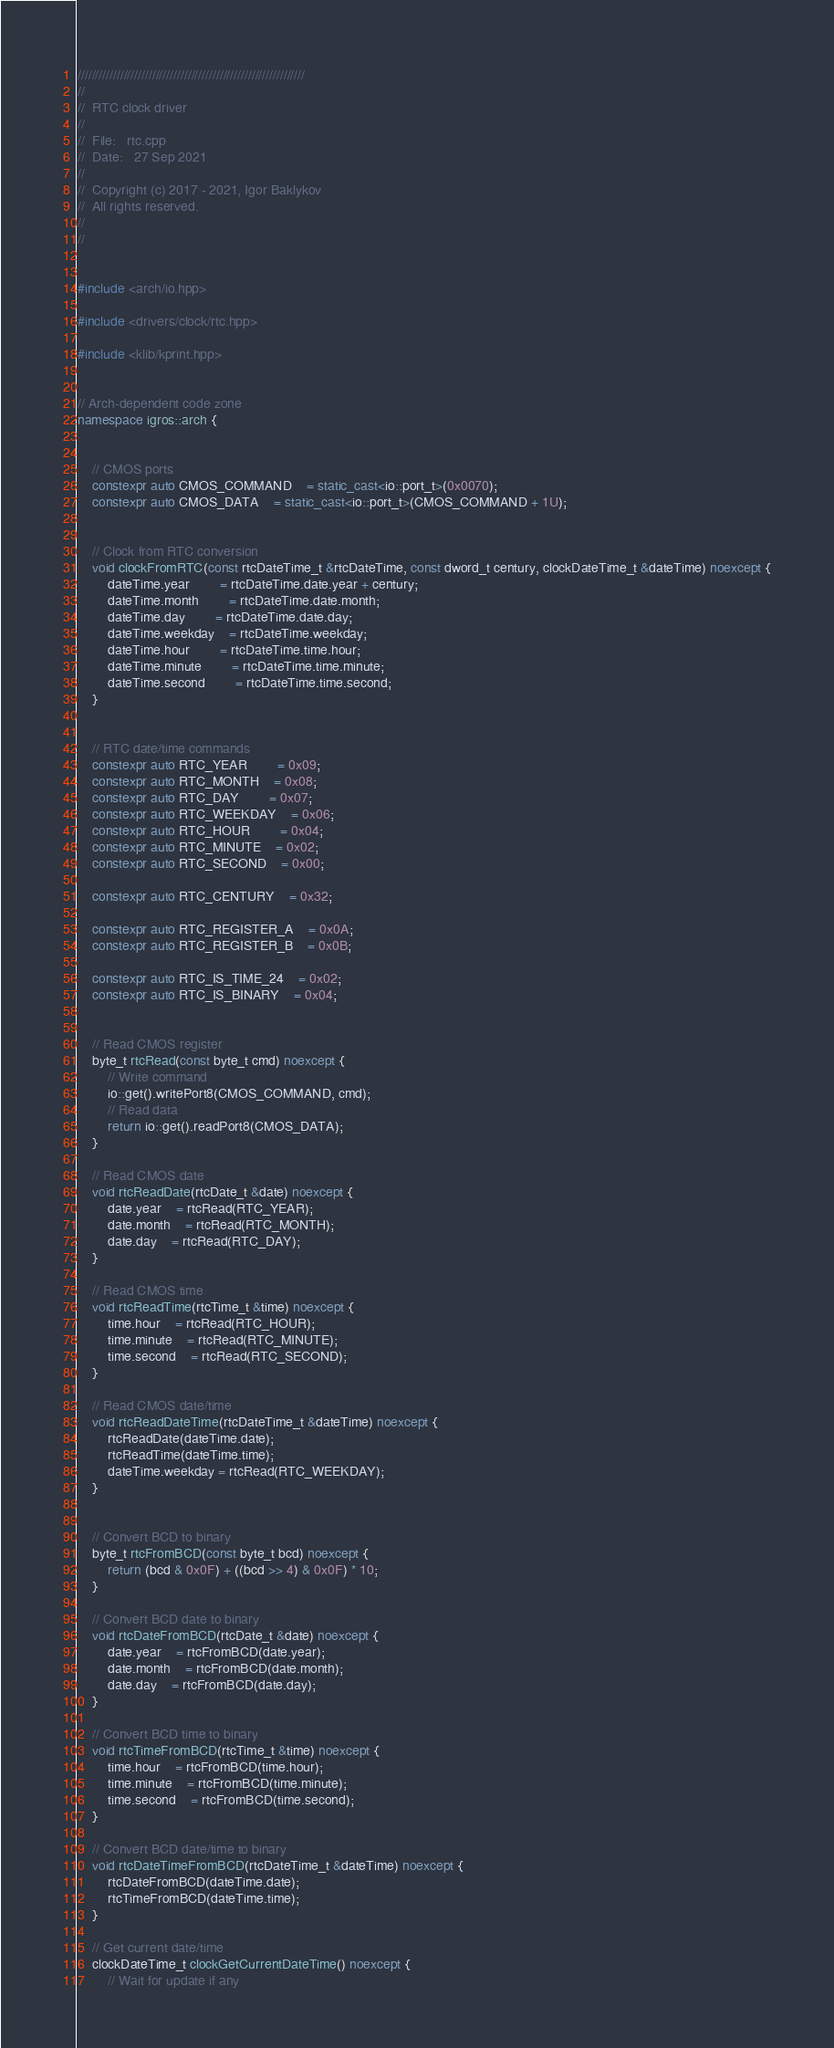<code> <loc_0><loc_0><loc_500><loc_500><_C++_>////////////////////////////////////////////////////////////////
//
//	RTC clock driver
//
//	File:	rtc.cpp
//	Date:	27 Sep 2021
//
//	Copyright (c) 2017 - 2021, Igor Baklykov
//	All rights reserved.
//
//


#include <arch/io.hpp>

#include <drivers/clock/rtc.hpp>

#include <klib/kprint.hpp>


// Arch-dependent code zone
namespace igros::arch {


	// CMOS ports
	constexpr auto CMOS_COMMAND	= static_cast<io::port_t>(0x0070);
	constexpr auto CMOS_DATA	= static_cast<io::port_t>(CMOS_COMMAND + 1U);


	// Clock from RTC conversion
	void clockFromRTC(const rtcDateTime_t &rtcDateTime, const dword_t century, clockDateTime_t &dateTime) noexcept {
		dateTime.year		= rtcDateTime.date.year + century;
		dateTime.month		= rtcDateTime.date.month;
		dateTime.day		= rtcDateTime.date.day;
		dateTime.weekday	= rtcDateTime.weekday;
		dateTime.hour		= rtcDateTime.time.hour;
		dateTime.minute		= rtcDateTime.time.minute;
		dateTime.second		= rtcDateTime.time.second;
	}


	// RTC date/time commands
	constexpr auto RTC_YEAR		= 0x09;
	constexpr auto RTC_MONTH	= 0x08;
	constexpr auto RTC_DAY		= 0x07;
	constexpr auto RTC_WEEKDAY	= 0x06;
	constexpr auto RTC_HOUR		= 0x04;
	constexpr auto RTC_MINUTE	= 0x02;
	constexpr auto RTC_SECOND	= 0x00;

	constexpr auto RTC_CENTURY	= 0x32;

	constexpr auto RTC_REGISTER_A	= 0x0A;
	constexpr auto RTC_REGISTER_B	= 0x0B;

	constexpr auto RTC_IS_TIME_24	= 0x02;
	constexpr auto RTC_IS_BINARY	= 0x04;


	// Read CMOS register
	byte_t rtcRead(const byte_t cmd) noexcept {
		// Write command
		io::get().writePort8(CMOS_COMMAND, cmd);
		// Read data
		return io::get().readPort8(CMOS_DATA);
	}

	// Read CMOS date
	void rtcReadDate(rtcDate_t &date) noexcept {
		date.year	= rtcRead(RTC_YEAR);
		date.month	= rtcRead(RTC_MONTH);
		date.day	= rtcRead(RTC_DAY);
	}

	// Read CMOS time
	void rtcReadTime(rtcTime_t &time) noexcept {
		time.hour	= rtcRead(RTC_HOUR);
		time.minute	= rtcRead(RTC_MINUTE);
		time.second	= rtcRead(RTC_SECOND);
	}

	// Read CMOS date/time
	void rtcReadDateTime(rtcDateTime_t &dateTime) noexcept {
		rtcReadDate(dateTime.date);
		rtcReadTime(dateTime.time);
		dateTime.weekday = rtcRead(RTC_WEEKDAY);
	}


	// Convert BCD to binary
	byte_t rtcFromBCD(const byte_t bcd) noexcept {
		return (bcd & 0x0F) + ((bcd >> 4) & 0x0F) * 10;
	}

	// Convert BCD date to binary
	void rtcDateFromBCD(rtcDate_t &date) noexcept {
		date.year	= rtcFromBCD(date.year);
		date.month	= rtcFromBCD(date.month);
		date.day	= rtcFromBCD(date.day);
	}

	// Convert BCD time to binary
	void rtcTimeFromBCD(rtcTime_t &time) noexcept {
		time.hour	= rtcFromBCD(time.hour);
		time.minute	= rtcFromBCD(time.minute);
		time.second	= rtcFromBCD(time.second);
	}

	// Convert BCD date/time to binary
	void rtcDateTimeFromBCD(rtcDateTime_t &dateTime) noexcept {
		rtcDateFromBCD(dateTime.date);
		rtcTimeFromBCD(dateTime.time);
	}

	// Get current date/time
	clockDateTime_t clockGetCurrentDateTime() noexcept {
		// Wait for update if any</code> 